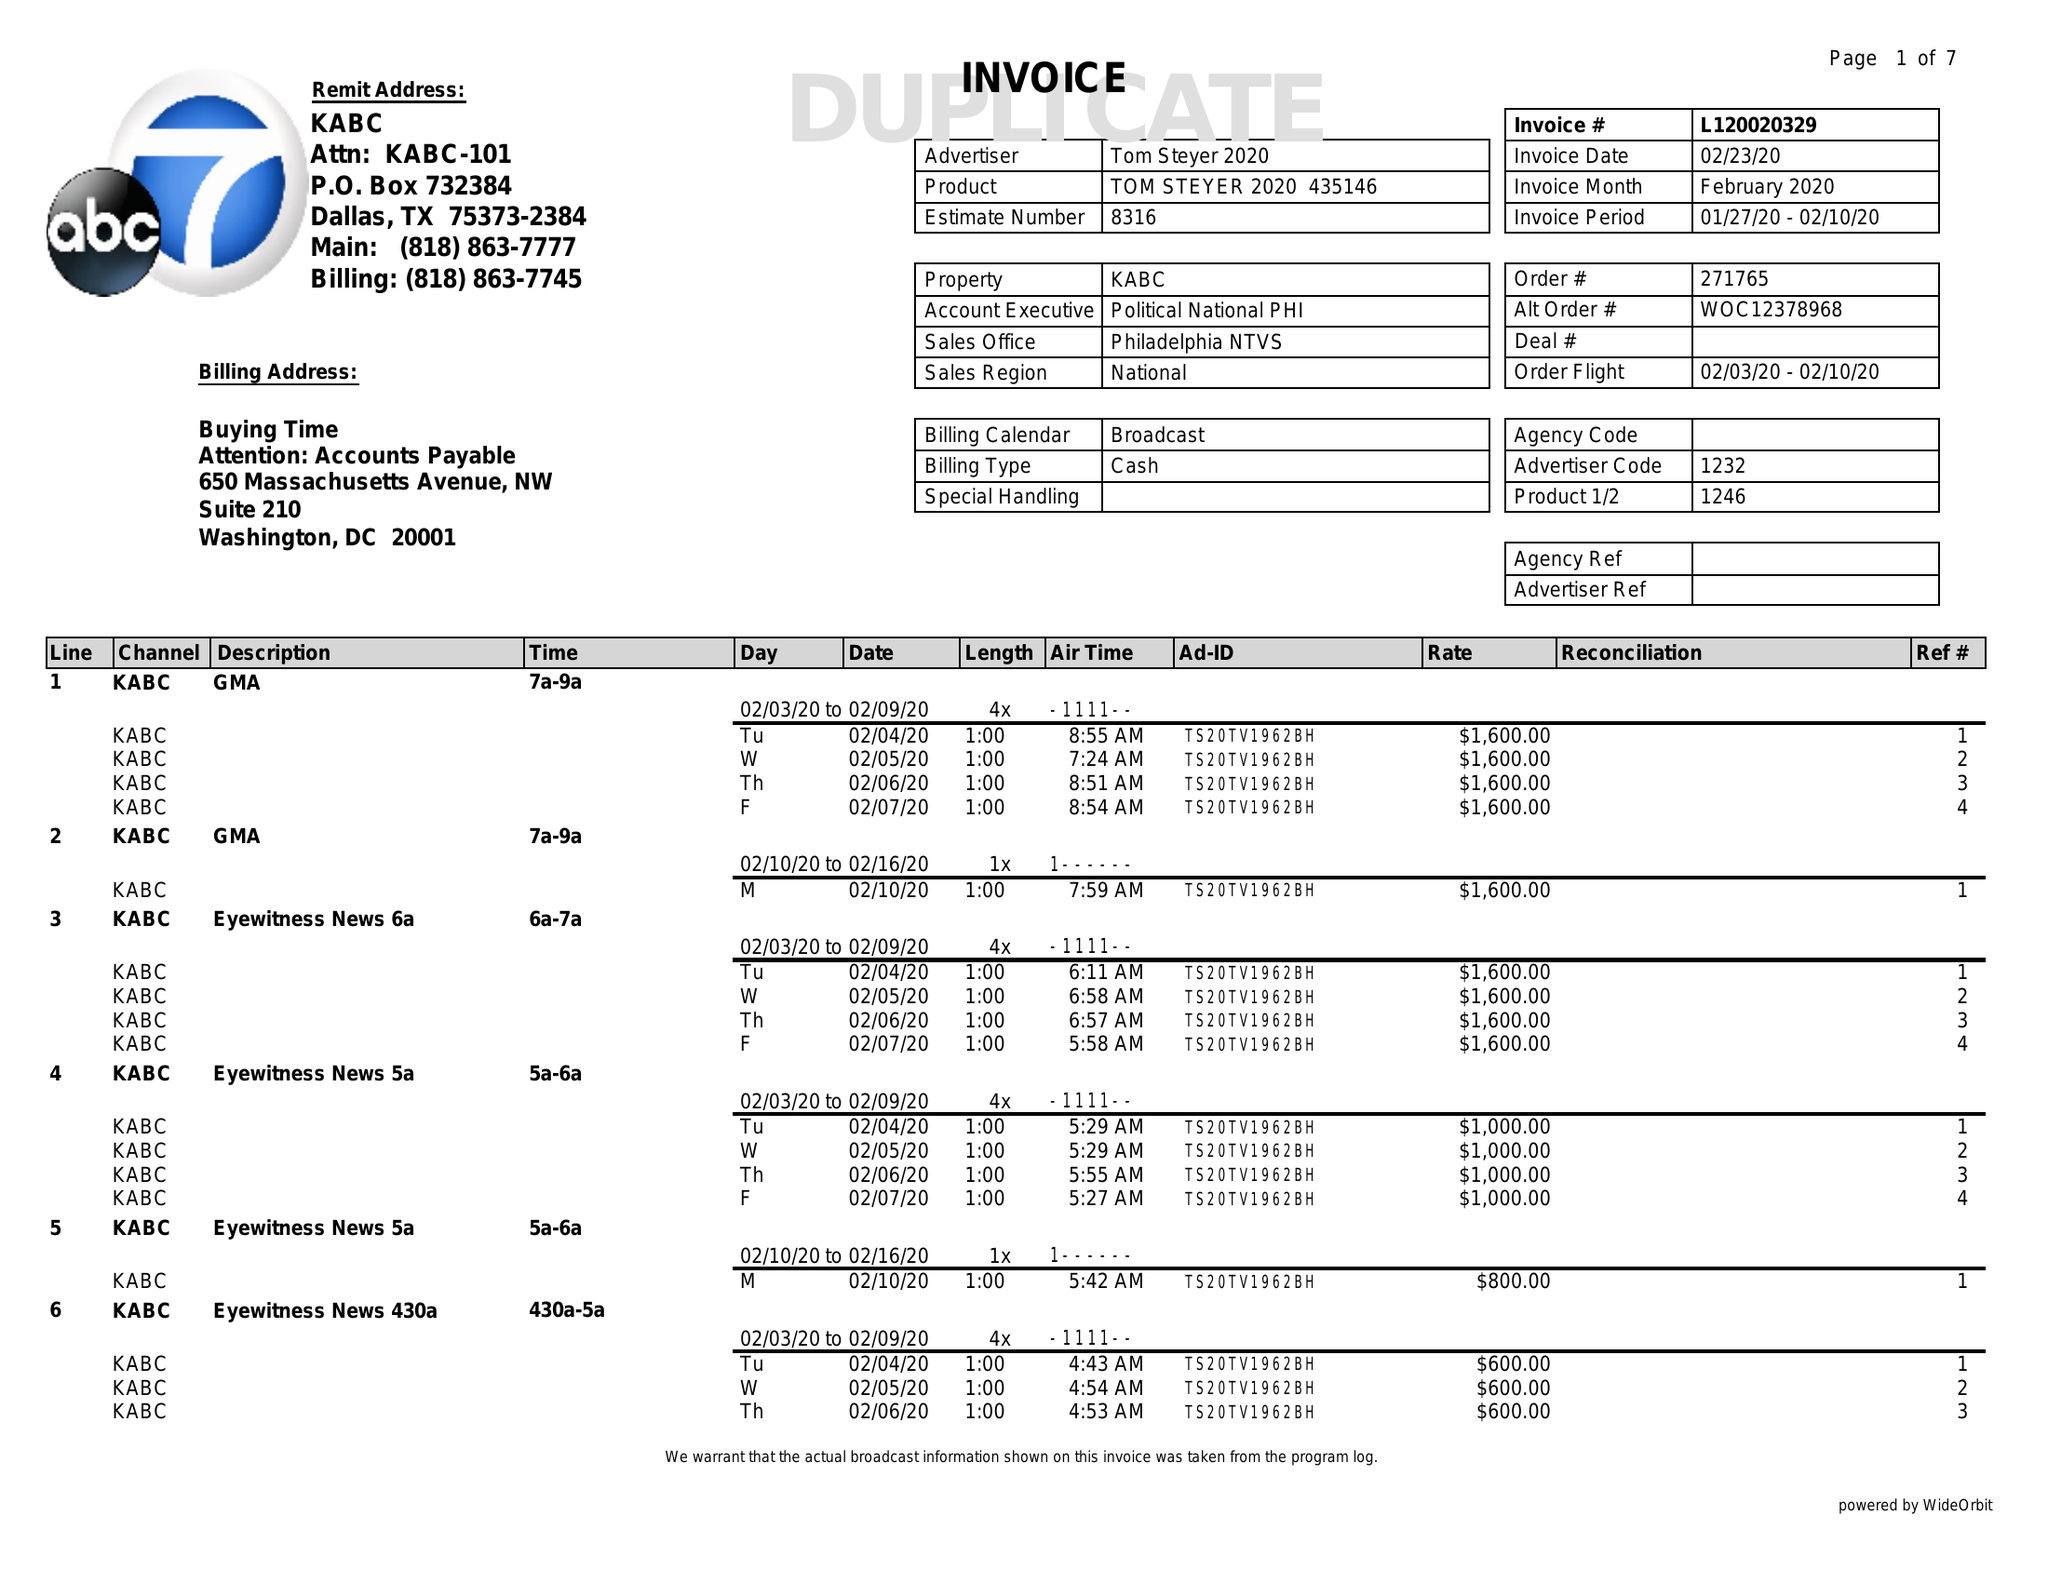What is the value for the advertiser?
Answer the question using a single word or phrase. TOM STEYER 2020 